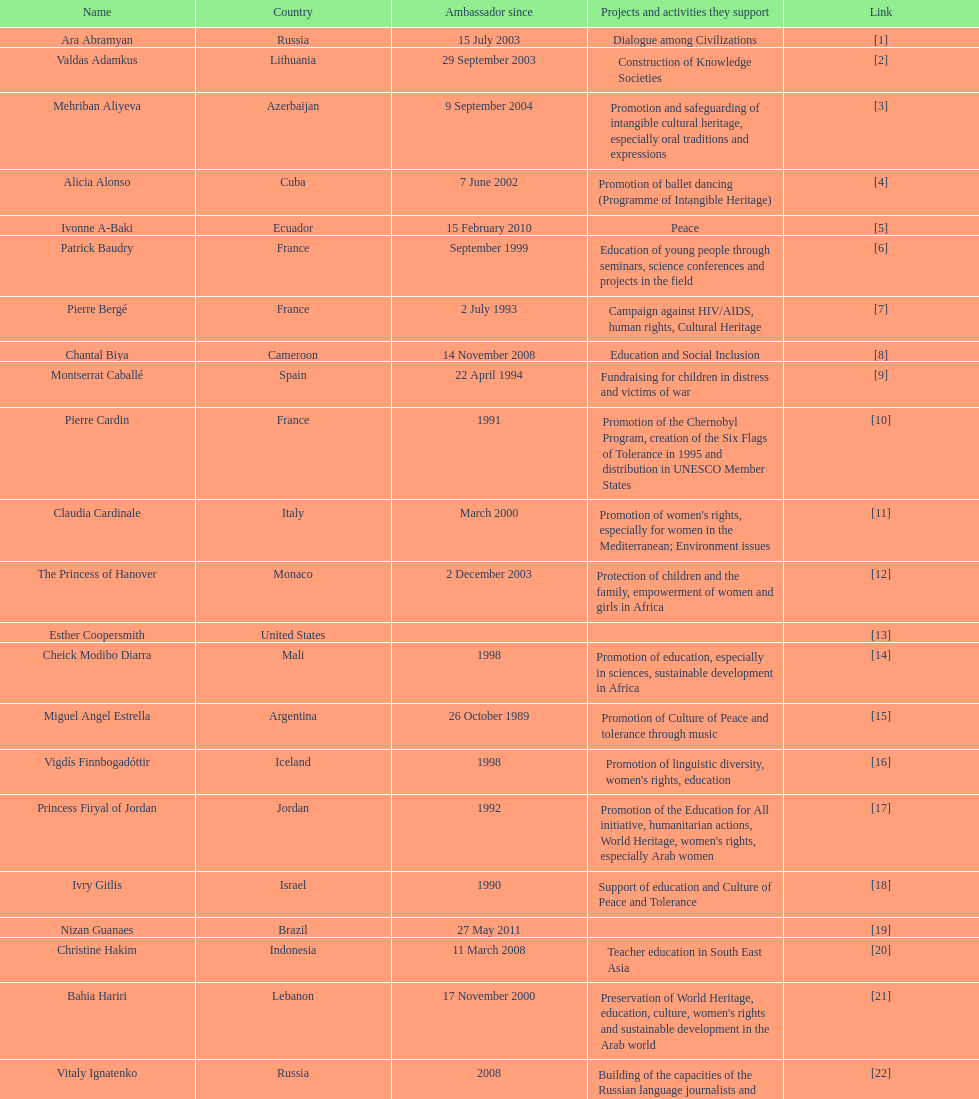Which unesco goodwill ambassador is most known for the promotion of the chernobyl program? Pierre Cardin. 